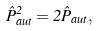<formula> <loc_0><loc_0><loc_500><loc_500>\hat { P } _ { a u t } ^ { 2 } = 2 \hat { P } _ { a u t } ,</formula> 